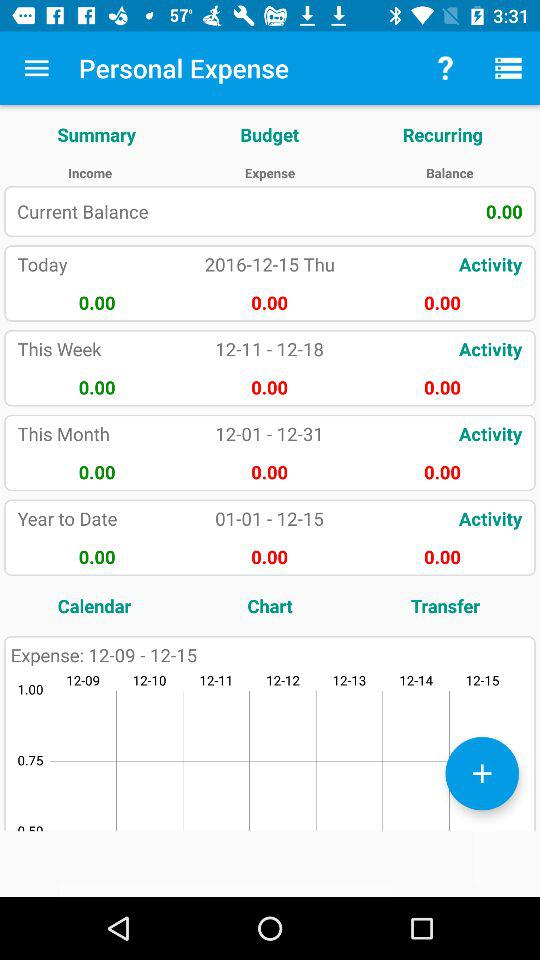What is the date range of the expense? The date ranges from December 9 to December 15. 